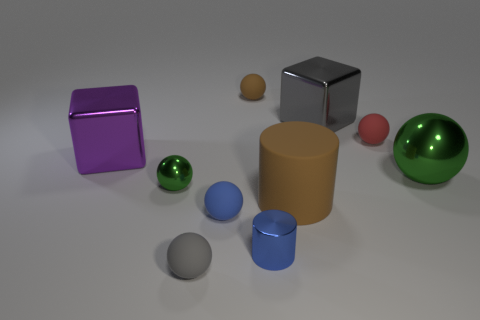Does the purple object have the same shape as the gray metallic thing?
Your response must be concise. Yes. How many shiny things are behind the big cylinder left of the green object on the right side of the small green object?
Give a very brief answer. 4. The thing that is both to the right of the big gray object and in front of the tiny red matte object is made of what material?
Provide a succinct answer. Metal. What color is the tiny rubber thing that is both behind the small blue metal object and to the left of the tiny brown rubber thing?
Offer a very short reply. Blue. There is a thing to the left of the metal sphere to the left of the small matte thing that is behind the red ball; what is its shape?
Provide a short and direct response. Cube. What color is the large metallic object that is the same shape as the tiny brown thing?
Your answer should be very brief. Green. The large block that is to the left of the ball that is in front of the blue ball is what color?
Offer a very short reply. Purple. What size is the other thing that is the same shape as the big brown rubber thing?
Give a very brief answer. Small. What number of tiny yellow cubes have the same material as the big gray cube?
Your answer should be very brief. 0. There is a tiny metal thing in front of the tiny green ball; how many shiny things are left of it?
Your response must be concise. 2. 